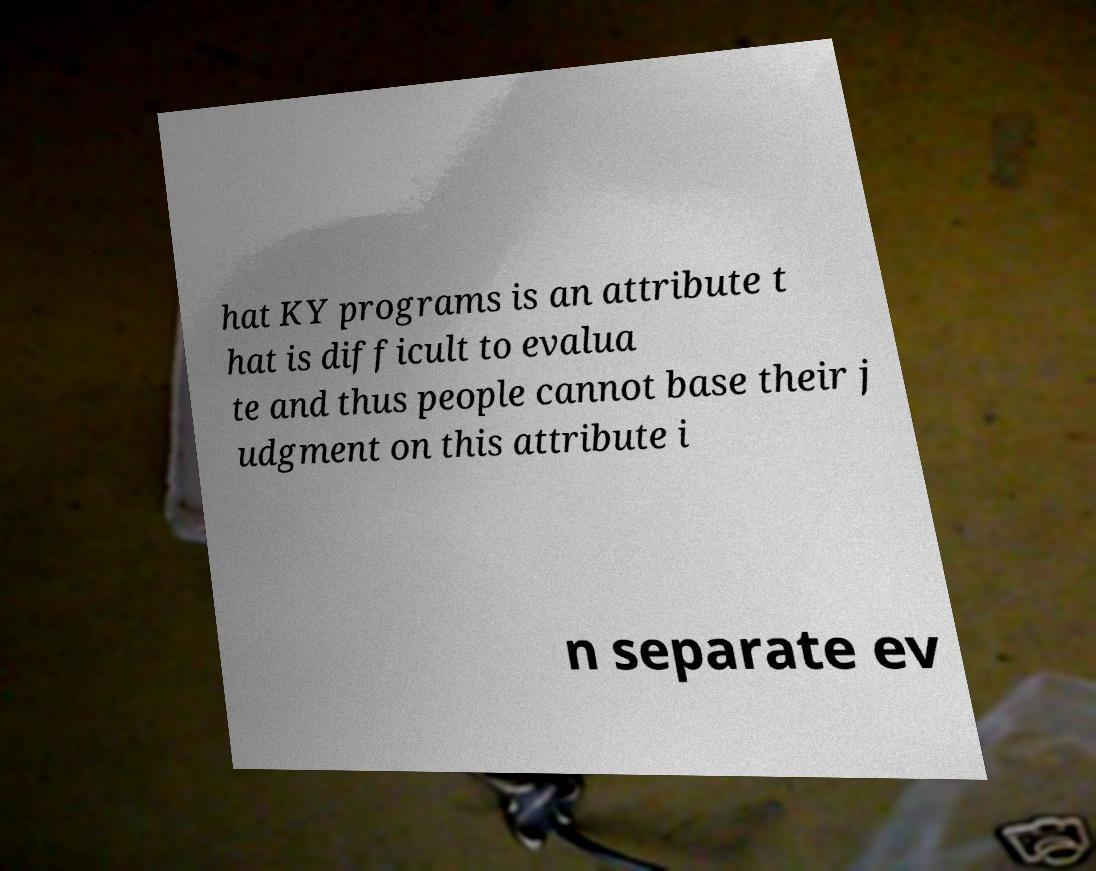Could you assist in decoding the text presented in this image and type it out clearly? hat KY programs is an attribute t hat is difficult to evalua te and thus people cannot base their j udgment on this attribute i n separate ev 